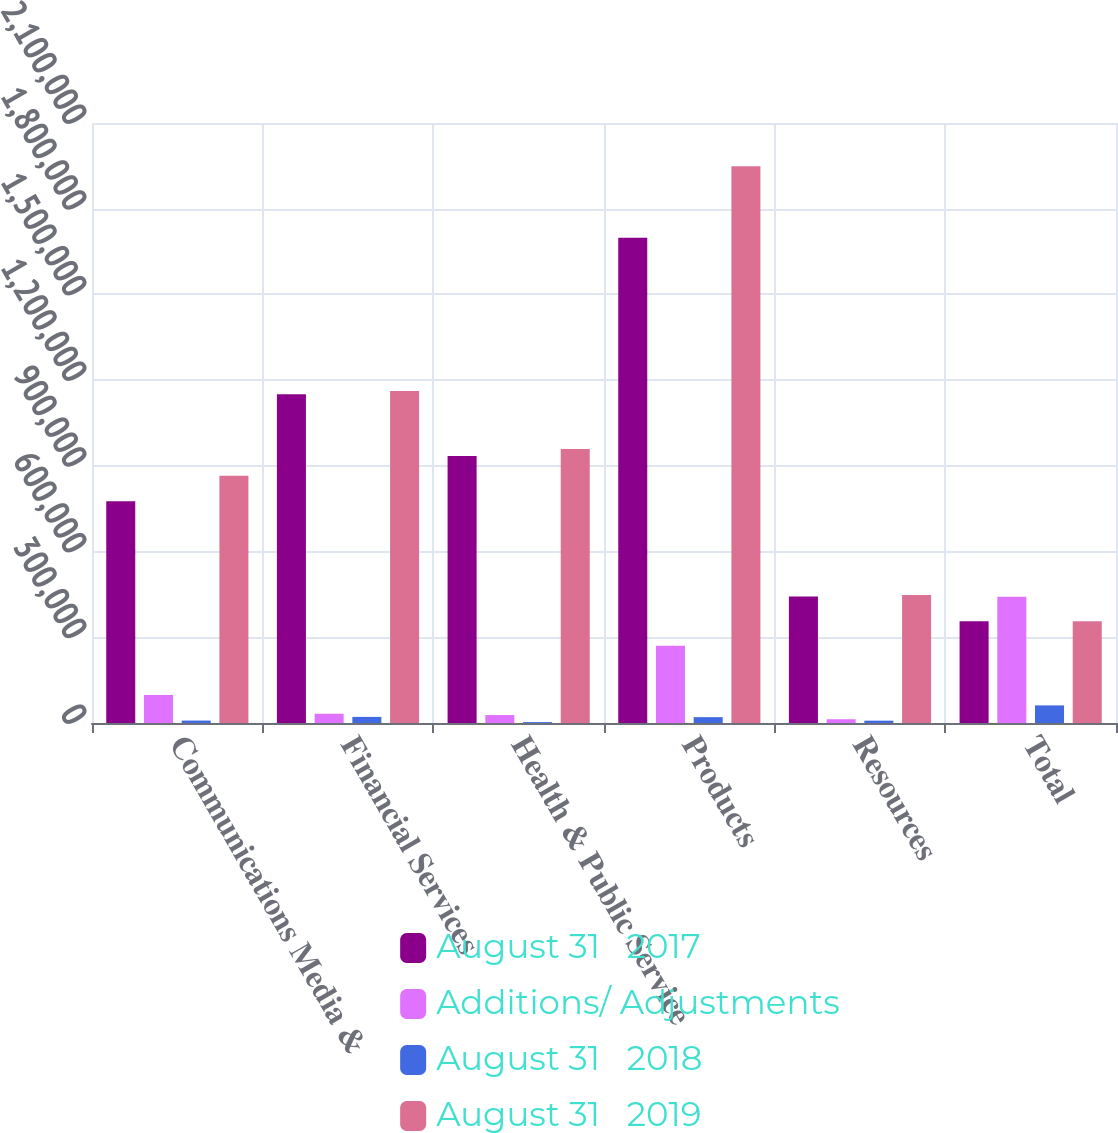Convert chart to OTSL. <chart><loc_0><loc_0><loc_500><loc_500><stacked_bar_chart><ecel><fcel>Communications Media &<fcel>Financial Services<fcel>Health & Public Service<fcel>Products<fcel>Resources<fcel>Total<nl><fcel>August 31   2017<fcel>775802<fcel>1.15102e+06<fcel>934374<fcel>1.69814e+06<fcel>443012<fcel>356497<nl><fcel>Additions/ Adjustments<fcel>98223<fcel>32390<fcel>27816<fcel>270701<fcel>13163<fcel>442293<nl><fcel>August 31   2018<fcel>8516<fcel>21348<fcel>3142<fcel>20440<fcel>8187<fcel>61633<nl><fcel>August 31   2019<fcel>865509<fcel>1.16207e+06<fcel>959048<fcel>1.9484e+06<fcel>447988<fcel>356497<nl></chart> 